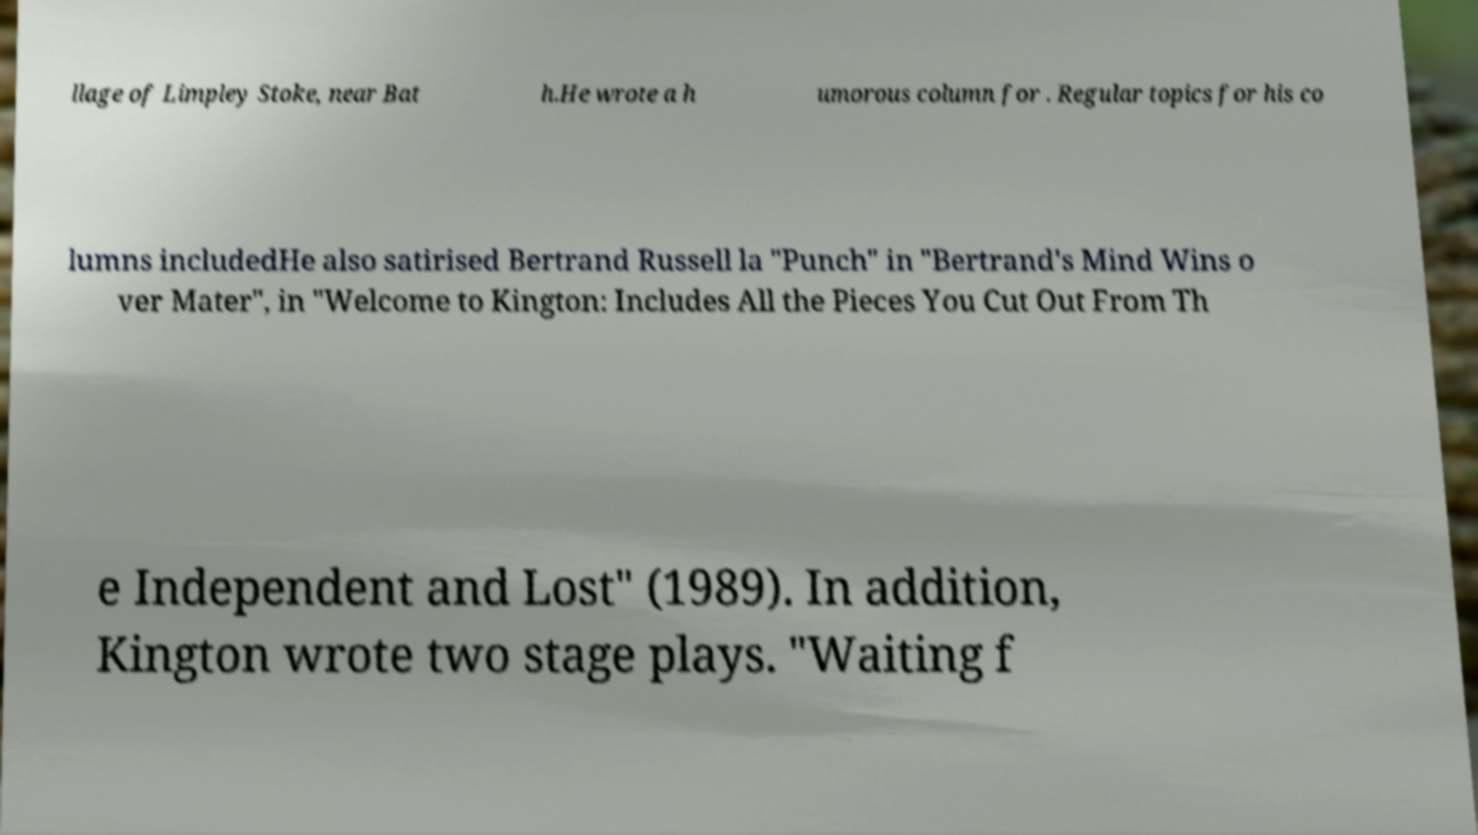Can you read and provide the text displayed in the image?This photo seems to have some interesting text. Can you extract and type it out for me? llage of Limpley Stoke, near Bat h.He wrote a h umorous column for . Regular topics for his co lumns includedHe also satirised Bertrand Russell la "Punch" in "Bertrand's Mind Wins o ver Mater", in "Welcome to Kington: Includes All the Pieces You Cut Out From Th e Independent and Lost" (1989). In addition, Kington wrote two stage plays. "Waiting f 